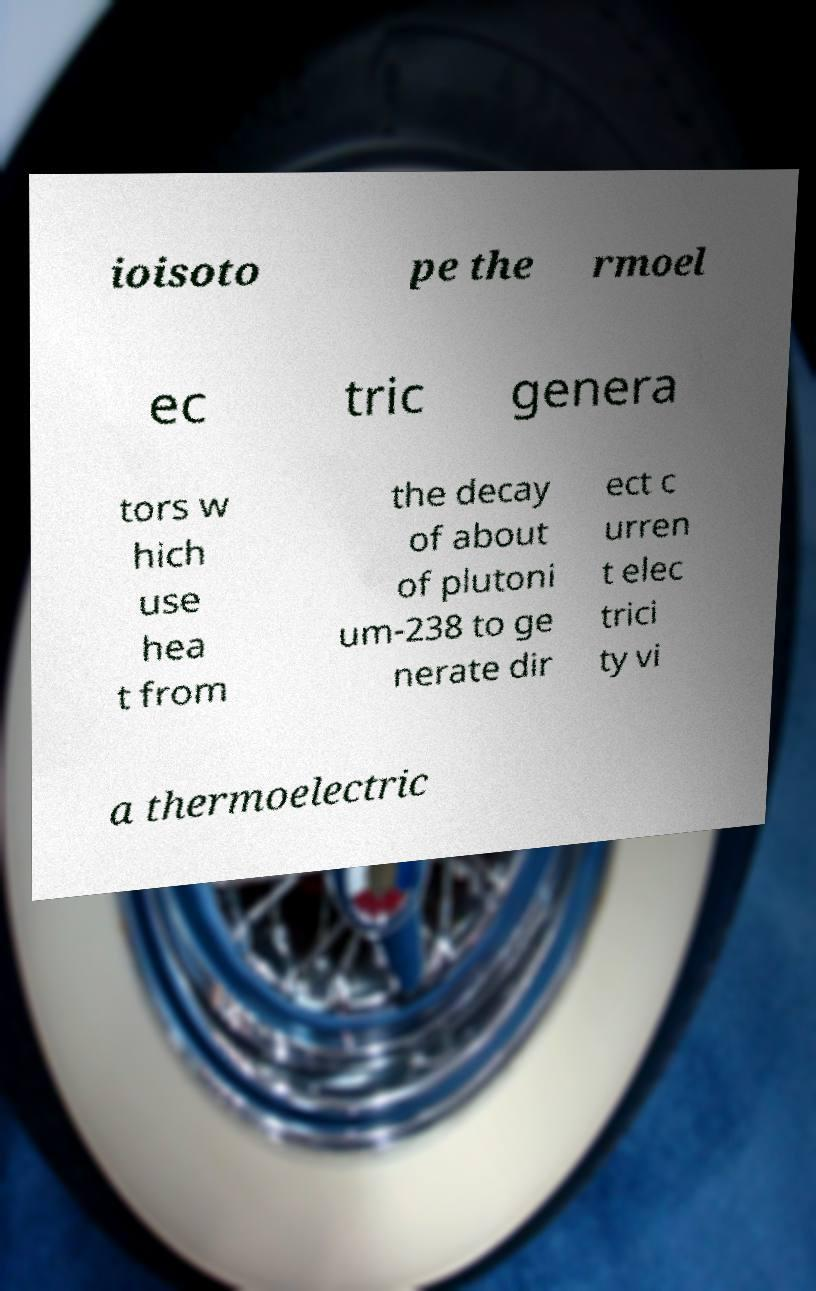There's text embedded in this image that I need extracted. Can you transcribe it verbatim? ioisoto pe the rmoel ec tric genera tors w hich use hea t from the decay of about of plutoni um-238 to ge nerate dir ect c urren t elec trici ty vi a thermoelectric 